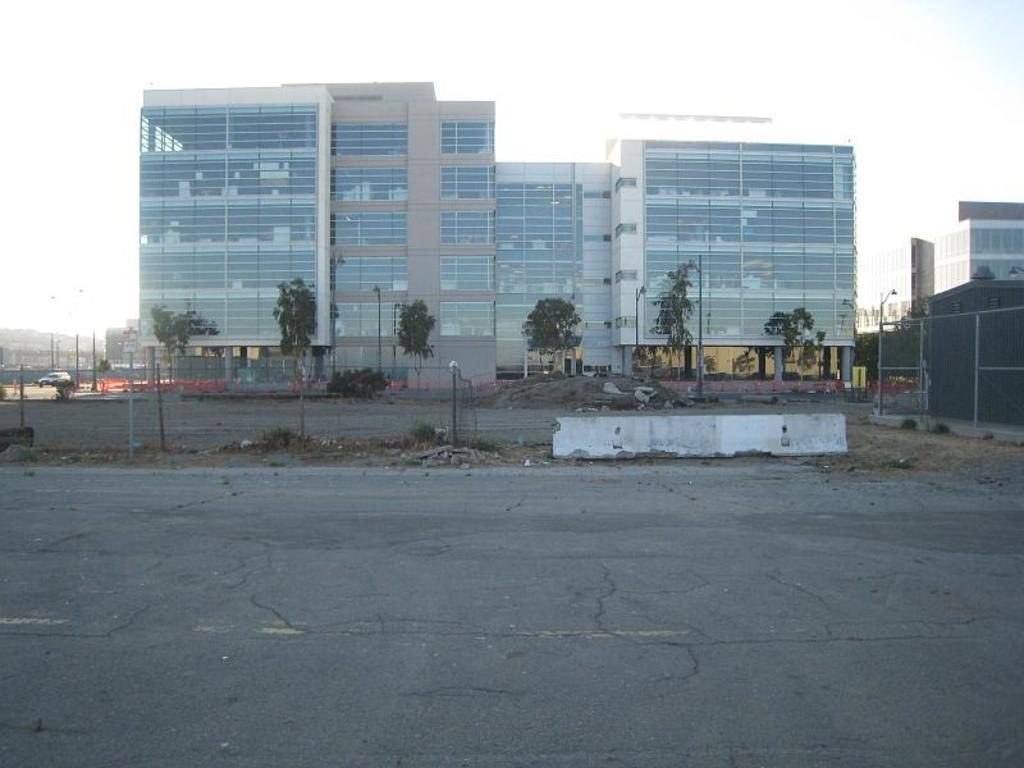What type of natural elements can be seen in the image? There are trees in the image. What type of man-made structures are present in the image? There are buildings in the image. What is located at the bottom of the image? There is a road at the bottom of the image. What objects can be seen in the middle of the image? There are poles in the middle of the image. What is visible at the top of the image? There is a sky at the top of the image. How many secretaries are present in the image? There is no mention of secretaries in the image; it features trees, buildings, a road, poles, and a sky. Can you describe the appearance of the women in the image? There is no mention of women in the image; it features trees, buildings, a road, poles, and a sky. 